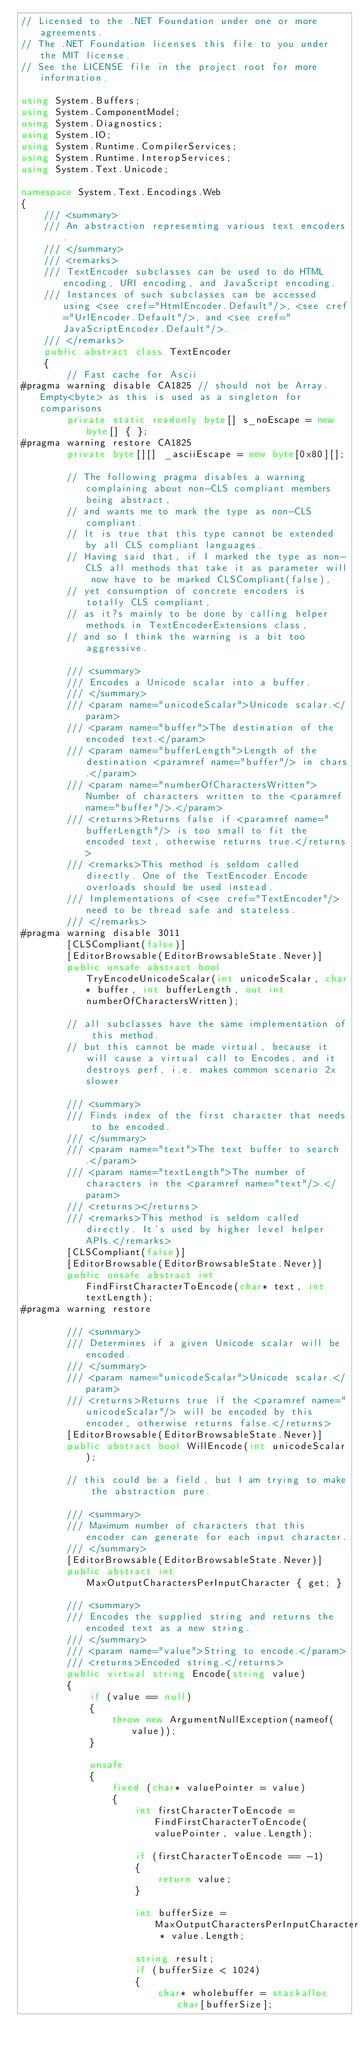<code> <loc_0><loc_0><loc_500><loc_500><_C#_>// Licensed to the .NET Foundation under one or more agreements.
// The .NET Foundation licenses this file to you under the MIT license.
// See the LICENSE file in the project root for more information.

using System.Buffers;
using System.ComponentModel;
using System.Diagnostics;
using System.IO;
using System.Runtime.CompilerServices;
using System.Runtime.InteropServices;
using System.Text.Unicode;

namespace System.Text.Encodings.Web
{
    /// <summary>
    /// An abstraction representing various text encoders. 
    /// </summary>
    /// <remarks>
    /// TextEncoder subclasses can be used to do HTML encoding, URI encoding, and JavaScript encoding. 
    /// Instances of such subclasses can be accessed using <see cref="HtmlEncoder.Default"/>, <see cref="UrlEncoder.Default"/>, and <see cref="JavaScriptEncoder.Default"/>.
    /// </remarks>
    public abstract class TextEncoder
    {
        // Fast cache for Ascii
#pragma warning disable CA1825 // should not be Array.Empty<byte> as this is used as a singleton for comparisons
        private static readonly byte[] s_noEscape = new byte[] { };
#pragma warning restore CA1825
        private byte[][] _asciiEscape = new byte[0x80][];
        
        // The following pragma disables a warning complaining about non-CLS compliant members being abstract, 
        // and wants me to mark the type as non-CLS compliant. 
        // It is true that this type cannot be extended by all CLS compliant languages. 
        // Having said that, if I marked the type as non-CLS all methods that take it as parameter will now have to be marked CLSCompliant(false), 
        // yet consumption of concrete encoders is totally CLS compliant, 
        // as it?s mainly to be done by calling helper methods in TextEncoderExtensions class, 
        // and so I think the warning is a bit too aggressive.  

        /// <summary>
        /// Encodes a Unicode scalar into a buffer.
        /// </summary>
        /// <param name="unicodeScalar">Unicode scalar.</param>
        /// <param name="buffer">The destination of the encoded text.</param>
        /// <param name="bufferLength">Length of the destination <paramref name="buffer"/> in chars.</param>
        /// <param name="numberOfCharactersWritten">Number of characters written to the <paramref name="buffer"/>.</param>
        /// <returns>Returns false if <paramref name="bufferLength"/> is too small to fit the encoded text, otherwise returns true.</returns>
        /// <remarks>This method is seldom called directly. One of the TextEncoder.Encode overloads should be used instead.
        /// Implementations of <see cref="TextEncoder"/> need to be thread safe and stateless.
        /// </remarks>
#pragma warning disable 3011
        [CLSCompliant(false)]
        [EditorBrowsable(EditorBrowsableState.Never)]
        public unsafe abstract bool TryEncodeUnicodeScalar(int unicodeScalar, char* buffer, int bufferLength, out int numberOfCharactersWritten);

        // all subclasses have the same implementation of this method.
        // but this cannot be made virtual, because it will cause a virtual call to Encodes, and it destroys perf, i.e. makes common scenario 2x slower 

        /// <summary>
        /// Finds index of the first character that needs to be encoded.
        /// </summary>
        /// <param name="text">The text buffer to search.</param>
        /// <param name="textLength">The number of characters in the <paramref name="text"/>.</param>
        /// <returns></returns>
        /// <remarks>This method is seldom called directly. It's used by higher level helper APIs.</remarks>
        [CLSCompliant(false)]
        [EditorBrowsable(EditorBrowsableState.Never)]
        public unsafe abstract int FindFirstCharacterToEncode(char* text, int textLength);
#pragma warning restore

        /// <summary>
        /// Determines if a given Unicode scalar will be encoded.
        /// </summary>
        /// <param name="unicodeScalar">Unicode scalar.</param>
        /// <returns>Returns true if the <paramref name="unicodeScalar"/> will be encoded by this encoder, otherwise returns false.</returns>
        [EditorBrowsable(EditorBrowsableState.Never)]
        public abstract bool WillEncode(int unicodeScalar);

        // this could be a field, but I am trying to make the abstraction pure.

        /// <summary>
        /// Maximum number of characters that this encoder can generate for each input character.
        /// </summary>
        [EditorBrowsable(EditorBrowsableState.Never)]
        public abstract int MaxOutputCharactersPerInputCharacter { get; }

        /// <summary>
        /// Encodes the supplied string and returns the encoded text as a new string.
        /// </summary>
        /// <param name="value">String to encode.</param>
        /// <returns>Encoded string.</returns>
        public virtual string Encode(string value)
        {
            if (value == null)
            {
                throw new ArgumentNullException(nameof(value));
            }

            unsafe
            {
                fixed (char* valuePointer = value)
                {
                    int firstCharacterToEncode = FindFirstCharacterToEncode(valuePointer, value.Length);

                    if (firstCharacterToEncode == -1)
                    {
                        return value;
                    }

                    int bufferSize = MaxOutputCharactersPerInputCharacter * value.Length;

                    string result;
                    if (bufferSize < 1024)
                    {
                        char* wholebuffer = stackalloc char[bufferSize];</code> 